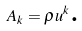Convert formula to latex. <formula><loc_0><loc_0><loc_500><loc_500>A _ { k } = \rho u ^ { k } \text {.}</formula> 